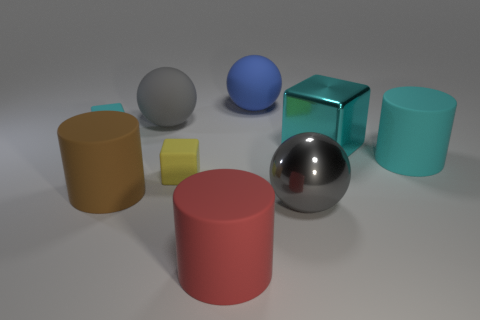What number of other things are made of the same material as the brown cylinder?
Offer a terse response. 6. How many things are either small cyan objects or small green things?
Provide a short and direct response. 1. Are there more balls in front of the brown cylinder than cyan matte blocks that are right of the tiny yellow block?
Your response must be concise. Yes. Do the large shiny thing behind the gray metallic sphere and the large rubber cylinder that is right of the red cylinder have the same color?
Your answer should be very brief. Yes. What size is the rubber cube that is in front of the tiny rubber object on the left side of the large gray sphere that is left of the blue rubber ball?
Your response must be concise. Small. The other tiny rubber thing that is the same shape as the tiny cyan object is what color?
Make the answer very short. Yellow. Is the number of large matte cylinders that are behind the yellow block greater than the number of large yellow matte cylinders?
Your answer should be compact. Yes. There is a yellow object; is it the same shape as the cyan matte thing that is on the left side of the big red thing?
Make the answer very short. Yes. What is the size of the cyan rubber thing that is the same shape as the yellow matte object?
Give a very brief answer. Small. Are there more small purple matte cylinders than tiny cyan rubber objects?
Offer a terse response. No. 